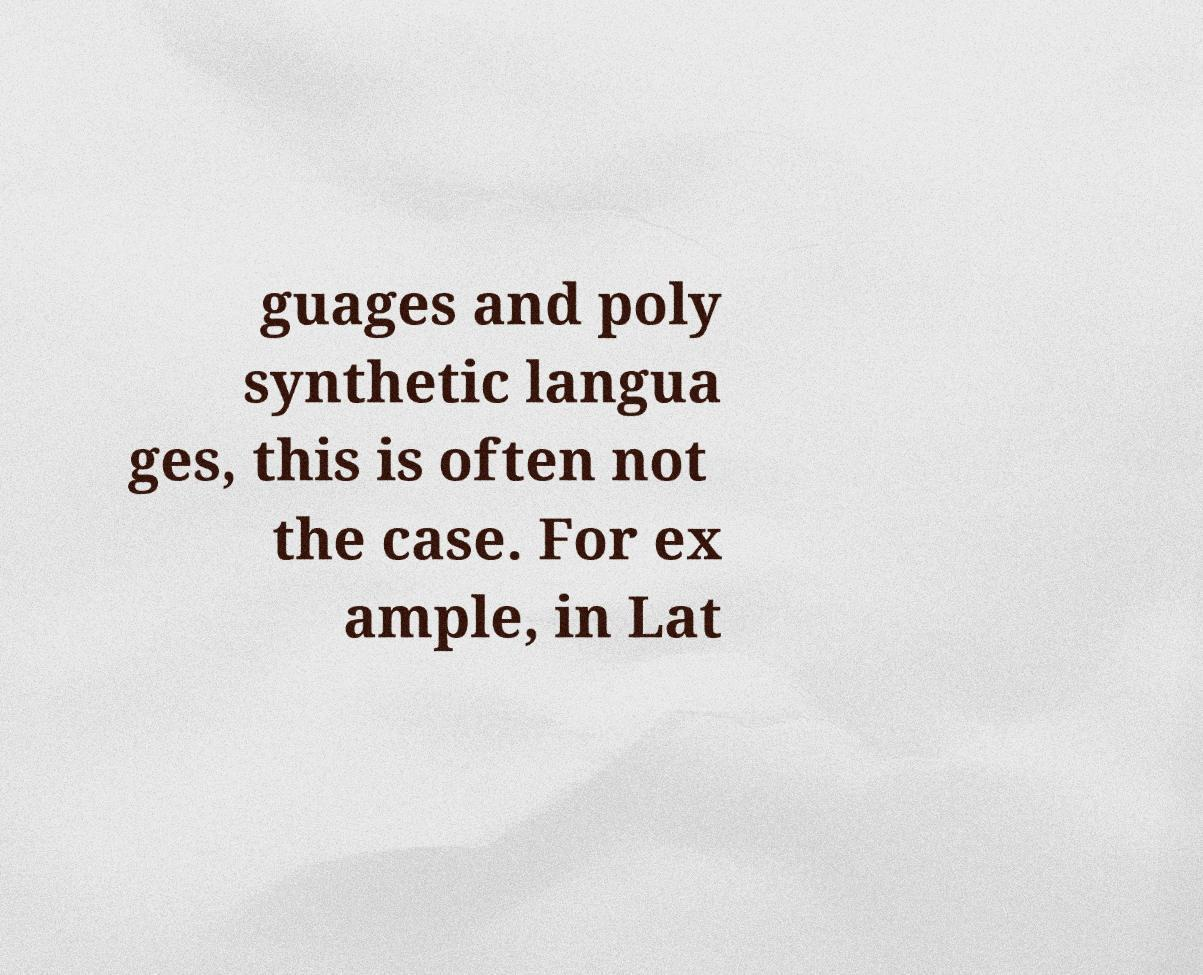Can you accurately transcribe the text from the provided image for me? guages and poly synthetic langua ges, this is often not the case. For ex ample, in Lat 